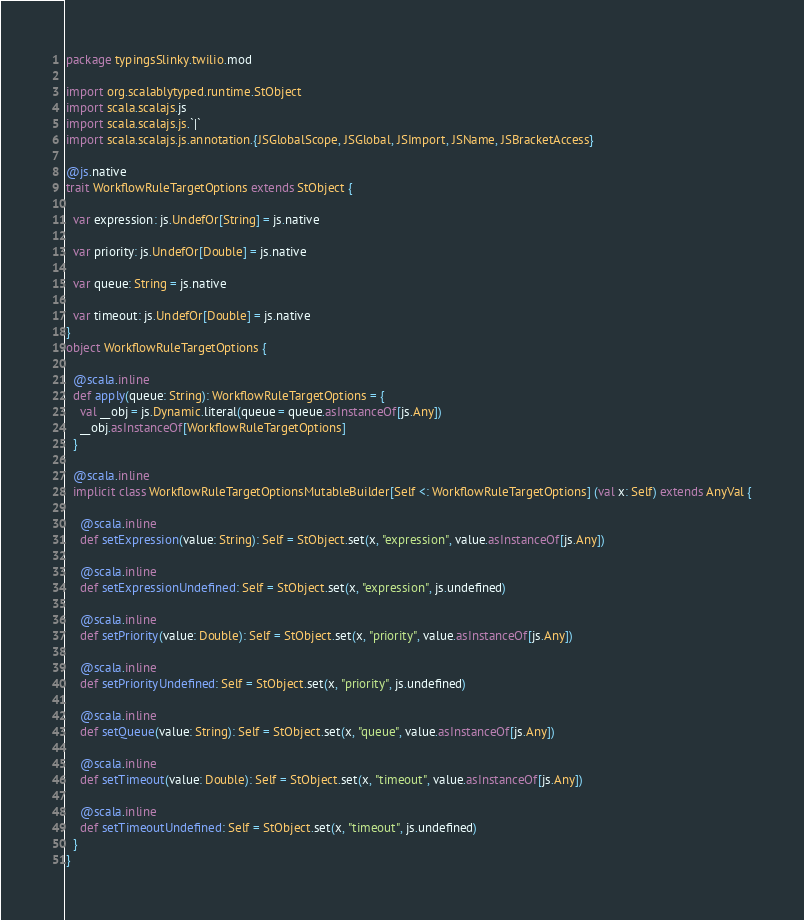Convert code to text. <code><loc_0><loc_0><loc_500><loc_500><_Scala_>package typingsSlinky.twilio.mod

import org.scalablytyped.runtime.StObject
import scala.scalajs.js
import scala.scalajs.js.`|`
import scala.scalajs.js.annotation.{JSGlobalScope, JSGlobal, JSImport, JSName, JSBracketAccess}

@js.native
trait WorkflowRuleTargetOptions extends StObject {
  
  var expression: js.UndefOr[String] = js.native
  
  var priority: js.UndefOr[Double] = js.native
  
  var queue: String = js.native
  
  var timeout: js.UndefOr[Double] = js.native
}
object WorkflowRuleTargetOptions {
  
  @scala.inline
  def apply(queue: String): WorkflowRuleTargetOptions = {
    val __obj = js.Dynamic.literal(queue = queue.asInstanceOf[js.Any])
    __obj.asInstanceOf[WorkflowRuleTargetOptions]
  }
  
  @scala.inline
  implicit class WorkflowRuleTargetOptionsMutableBuilder[Self <: WorkflowRuleTargetOptions] (val x: Self) extends AnyVal {
    
    @scala.inline
    def setExpression(value: String): Self = StObject.set(x, "expression", value.asInstanceOf[js.Any])
    
    @scala.inline
    def setExpressionUndefined: Self = StObject.set(x, "expression", js.undefined)
    
    @scala.inline
    def setPriority(value: Double): Self = StObject.set(x, "priority", value.asInstanceOf[js.Any])
    
    @scala.inline
    def setPriorityUndefined: Self = StObject.set(x, "priority", js.undefined)
    
    @scala.inline
    def setQueue(value: String): Self = StObject.set(x, "queue", value.asInstanceOf[js.Any])
    
    @scala.inline
    def setTimeout(value: Double): Self = StObject.set(x, "timeout", value.asInstanceOf[js.Any])
    
    @scala.inline
    def setTimeoutUndefined: Self = StObject.set(x, "timeout", js.undefined)
  }
}
</code> 